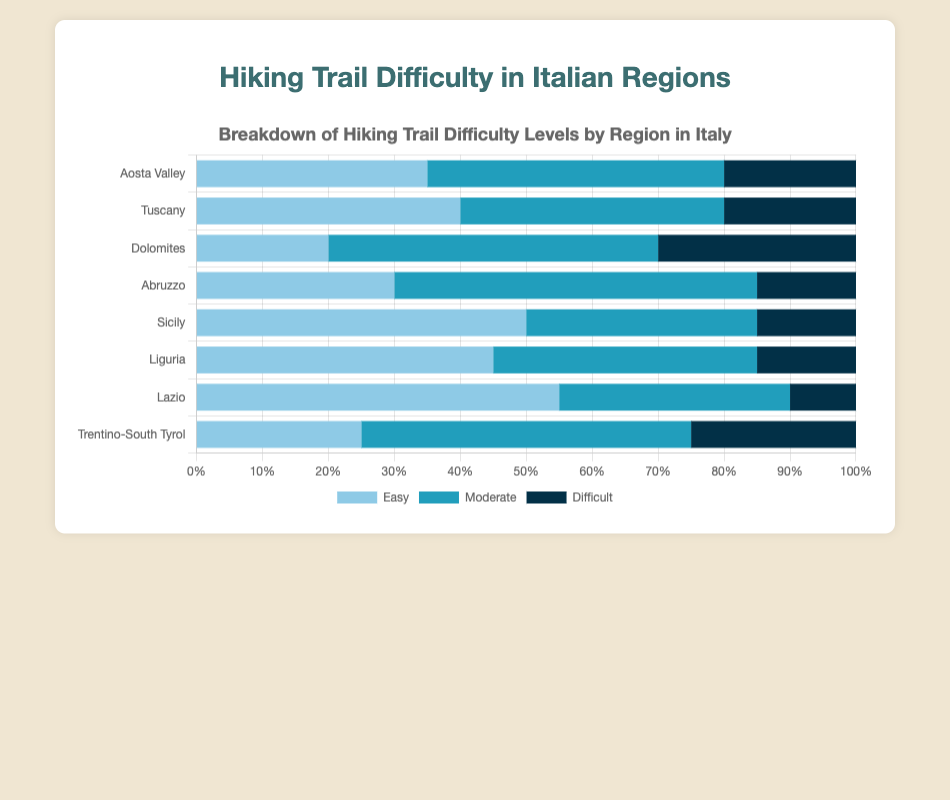Which region has the highest percentage of easy trails? Observe the bars representing "easy" trails and compare their lengths. The region Lazio has the longest bar in the "easy" category at 55%.
Answer: Lazio Which region has the highest percentage of difficult trails? Look at the bars representing "difficult" trails. The Dolomites region has the longest bar in the "difficult" category at 30%.
Answer: Dolomites Which regions have the same percentage of moderate trails? Compare the bars representing "moderate" trails, noting the lengths. Tuscany and Liguria both have a "moderate" trail percentage of 40%.
Answer: Tuscany, Liguria In the Dolomites, what is the combined percentage of easy and difficult trails? Add the percentages for "easy" and "difficult" trails in the Dolomites. Easy is 20% and difficult is 30%, so 20% + 30% = 50%.
Answer: 50% Which region has the smallest percentage of difficult trails? Identify the shortest bar in the "difficult" category. Lazio has the smallest percentage at 10%.
Answer: Lazio How does the percentage of moderate trails in Abruzzo compare to that in Lazio? Find and compare the lengths of the bars representing "moderate" trails for Abruzzo and Lazio. Abruzzo has 55% while Lazio has 35%, so Abruzzo is higher.
Answer: Abruzzo is higher What is the percentage difference between easy trails in Sicily and Aosta Valley? Subtract the percentage of easy trails in Aosta Valley from that in Sicily. Sicily has 50% and Aosta Valley has 35%, so 50% - 35% = 15%.
Answer: 15% If you combine easy and moderate trails, which region has the highest percentage sum? Add the percentages of easy and moderate trails for all regions and compare. Lazio has the highest sum with 55% (easy) + 35% (moderate) = 90%.
Answer: Lazio Which region has the most balanced distribution of easy, moderate, and difficult trails? Compare the regions to see which one has the smallest range between the highest and lowest trail percentages. Tuscany has easy (40%), moderate (40%), and difficult (20%) with a range of 20%.
Answer: Tuscany 